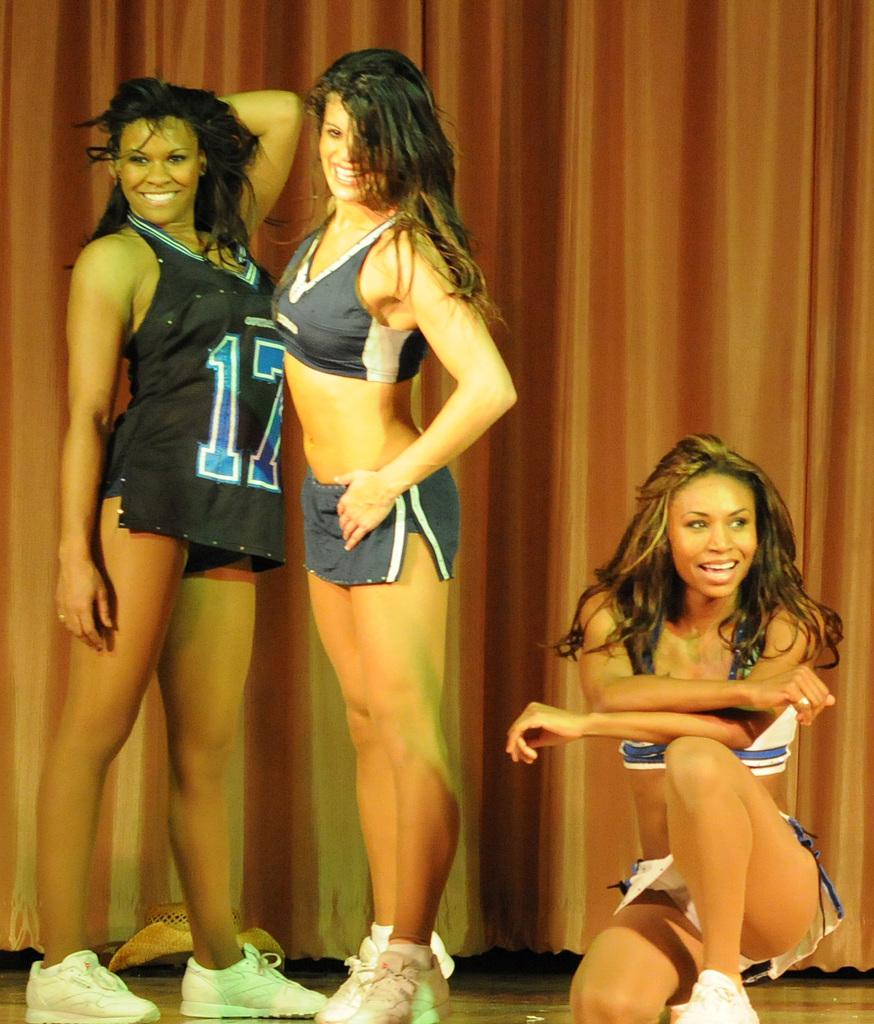What is the number on the girl shirt on the left ?
Keep it short and to the point. 17. The color of the number 17 is?
Provide a short and direct response. Blue. 